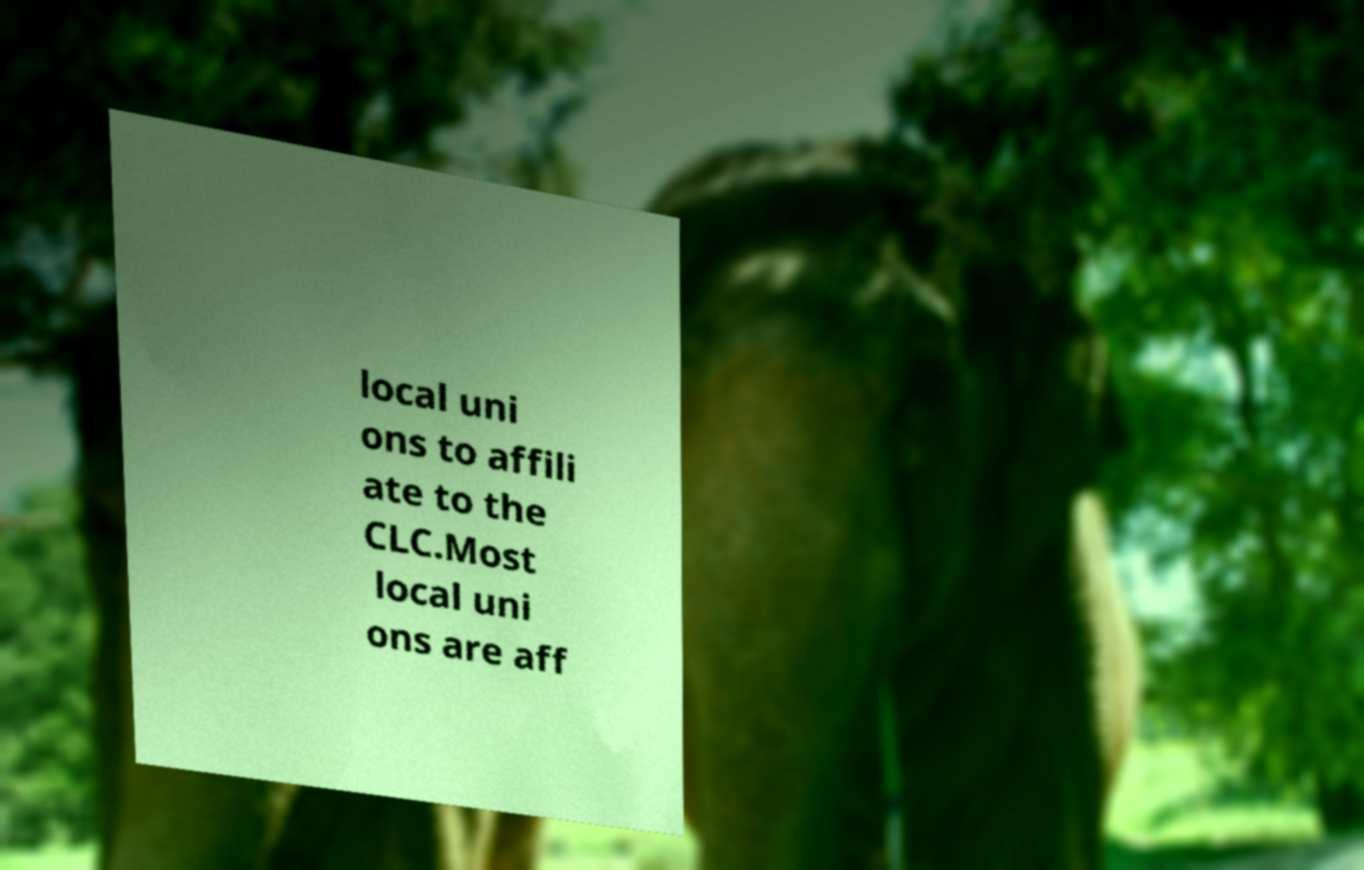I need the written content from this picture converted into text. Can you do that? local uni ons to affili ate to the CLC.Most local uni ons are aff 